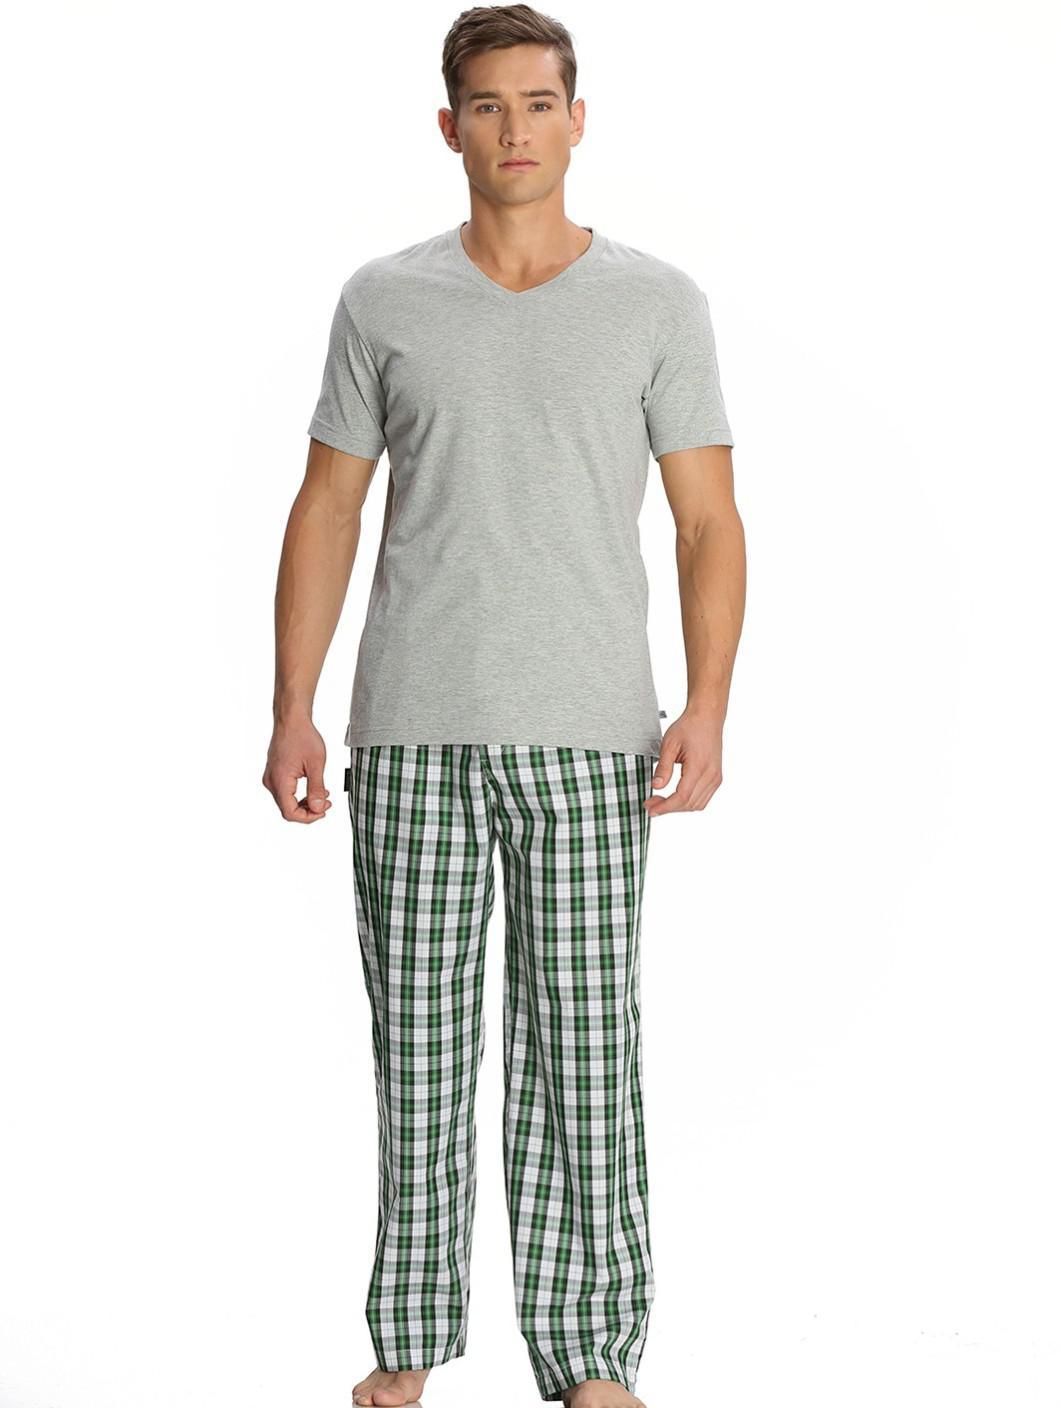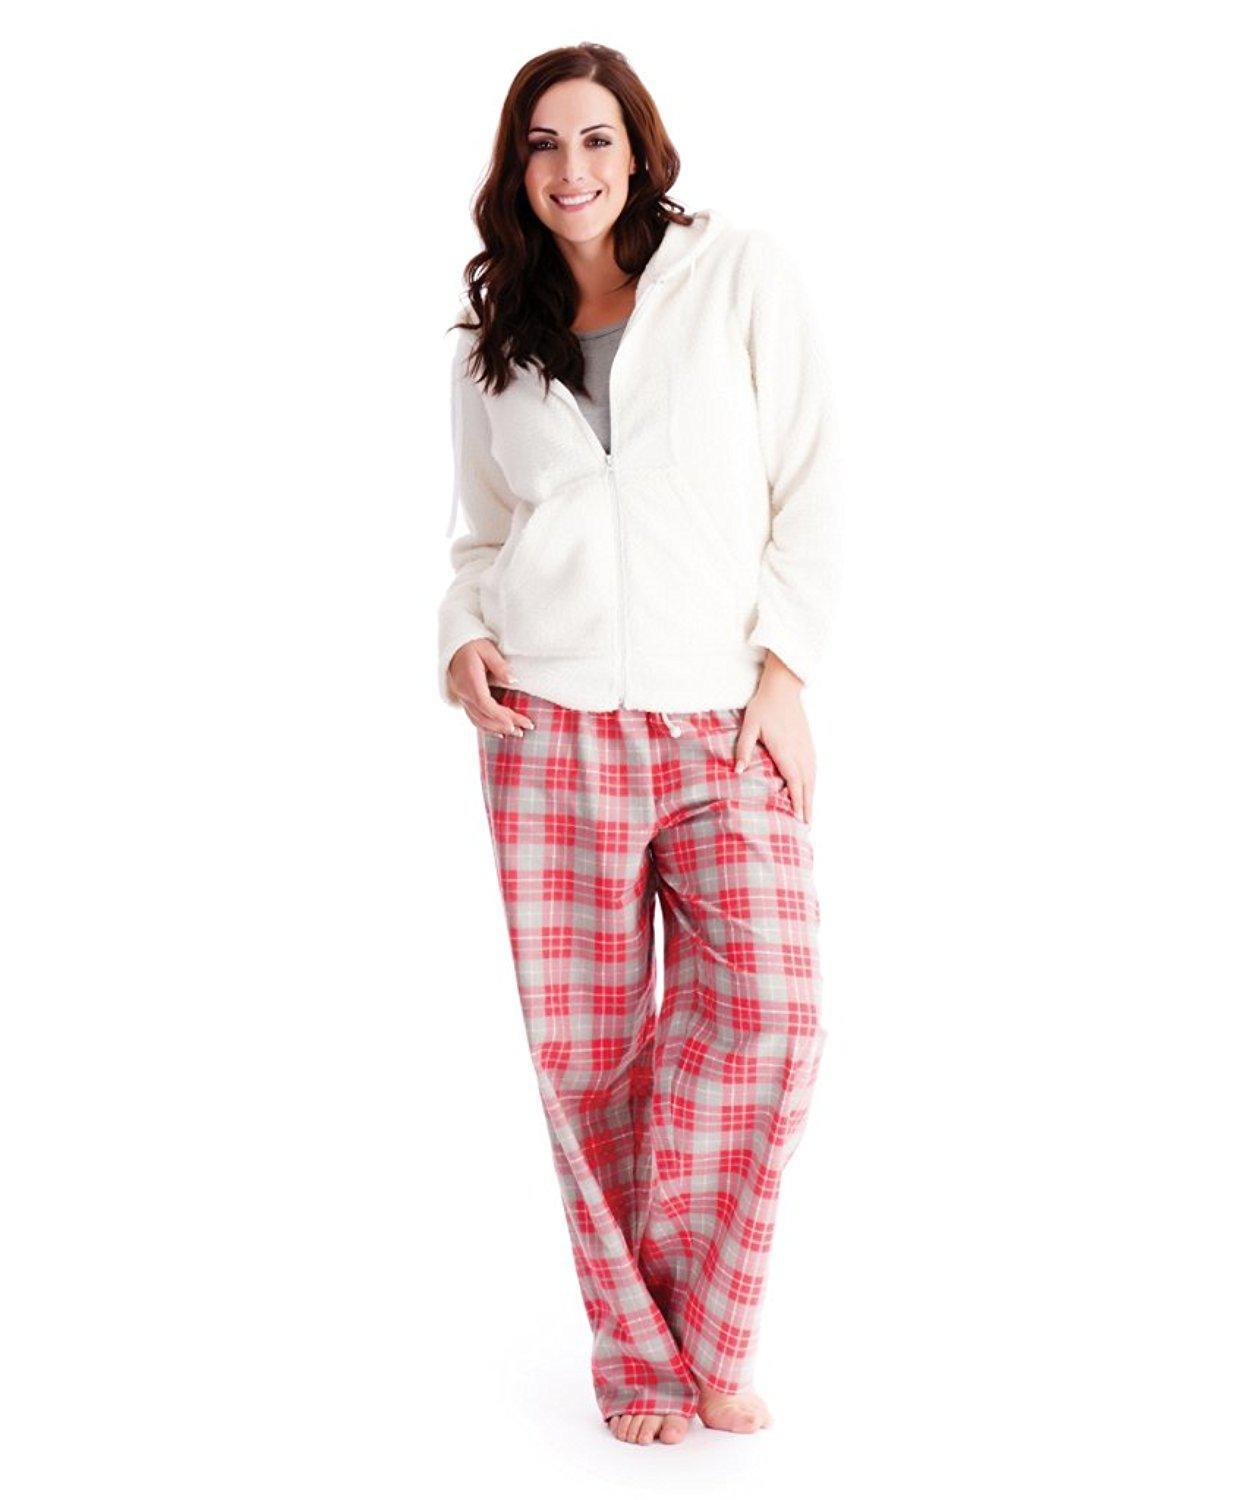The first image is the image on the left, the second image is the image on the right. Analyze the images presented: Is the assertion "There is a woman leaning on her right leg in the left image." valid? Answer yes or no. No. The first image is the image on the left, the second image is the image on the right. Examine the images to the left and right. Is the description "There is a person with one arm raised so that that hand is approximately level with their shoulder." accurate? Answer yes or no. No. 